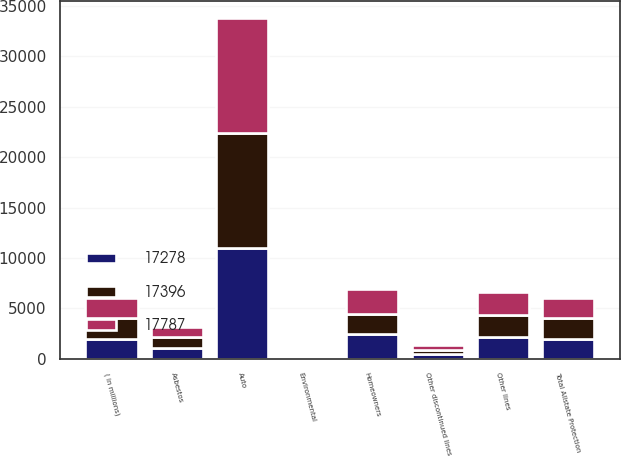Convert chart. <chart><loc_0><loc_0><loc_500><loc_500><stacked_bar_chart><ecel><fcel>( in millions)<fcel>Auto<fcel>Homeowners<fcel>Other lines<fcel>Total Allstate Protection<fcel>Asbestos<fcel>Environmental<fcel>Other discontinued lines<nl><fcel>17396<fcel>2012<fcel>11383<fcel>2008<fcel>2250<fcel>2010<fcel>1026<fcel>193<fcel>418<nl><fcel>17787<fcel>2011<fcel>11404<fcel>2439<fcel>2237<fcel>2010<fcel>1078<fcel>185<fcel>444<nl><fcel>17278<fcel>2010<fcel>11034<fcel>2442<fcel>2141<fcel>2010<fcel>1100<fcel>201<fcel>478<nl></chart> 